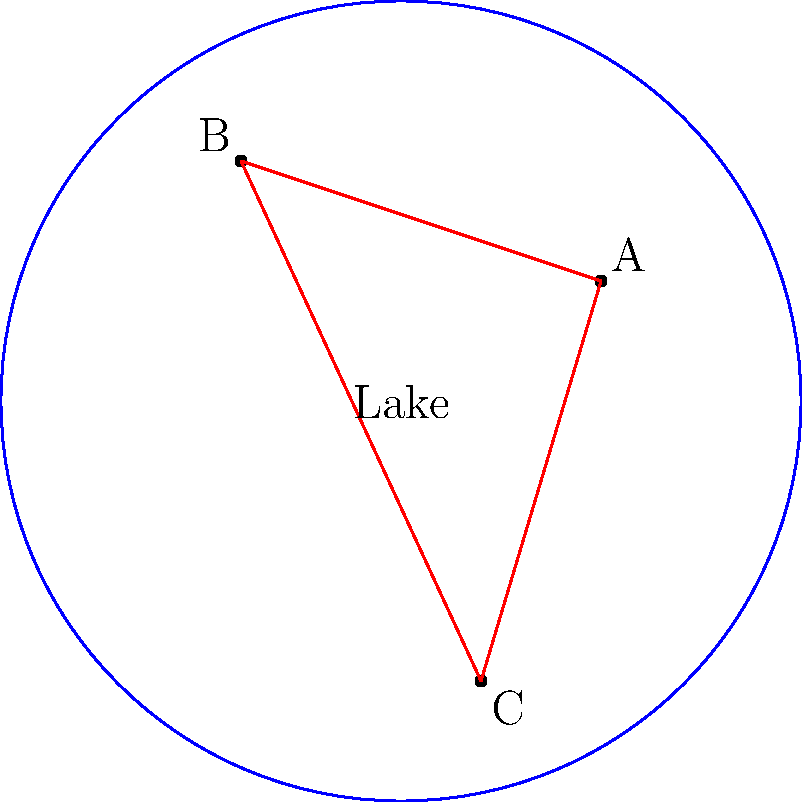In the Poincaré disk model of hyperbolic geometry representing a circular lake and its surroundings, three properties (A, B, and C) are located as shown in the diagram. If the hyperbolic distance between A and B is 2 units, and the distance between B and C is 3 units, what is the hyperbolic distance between A and C? To solve this problem, we need to use the hyperbolic law of cosines in the Poincaré disk model. Let's approach this step-by-step:

1) In hyperbolic geometry, the law of cosines states:

   $$\cosh(c) = \cosh(a)\cosh(b) - \sinh(a)\sinh(b)\cos(C)$$

   Where a, b, and c are the lengths of the sides of the hyperbolic triangle, and C is the angle opposite side c.

2) We know that:
   - The distance between A and B (let's call it a) is 2 units
   - The distance between B and C (let's call it b) is 3 units
   - We need to find the distance between A and C (let's call it c)

3) We need to find the angle C. In the Poincaré disk model, angles are preserved, so we can measure the Euclidean angle in the diagram. However, this information is not provided, so we need to consider the worst-case scenario.

4) The worst-case scenario (maximum possible distance) occurs when the angle C is 180 degrees or π radians. In this case, cos(C) = -1.

5) Substituting these values into the hyperbolic law of cosines:

   $$\cosh(c) = \cosh(2)\cosh(3) - \sinh(2)\sinh(3)(-1)$$

6) Simplify:
   $$\cosh(c) = \cosh(2)\cosh(3) + \sinh(2)\sinh(3)$$

7) Calculate:
   $$\cosh(c) \approx 3.7622 \cdot 10.0677 + 3.6269 \cdot 10.0179 \approx 74.2099$$

8) To find c, we need to take the inverse hyperbolic cosine (arccosh):

   $$c = \text{arccosh}(74.2099) \approx 5.0033$$

Therefore, the maximum hyperbolic distance between A and C is approximately 5 units.
Answer: 5 units 